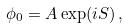<formula> <loc_0><loc_0><loc_500><loc_500>\phi _ { 0 } = A \exp ( i S ) \, ,</formula> 